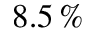<formula> <loc_0><loc_0><loc_500><loc_500>8 . 5 \, \%</formula> 